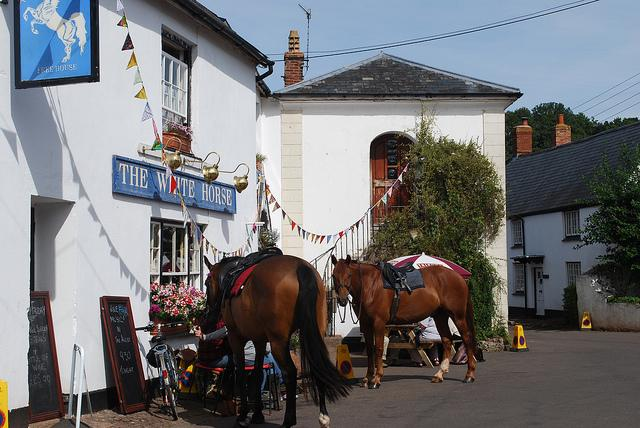What type of movie would this scene appear in?

Choices:
A) mountaintop mystery
B) bowling documentary
C) western
D) swimming drama western 